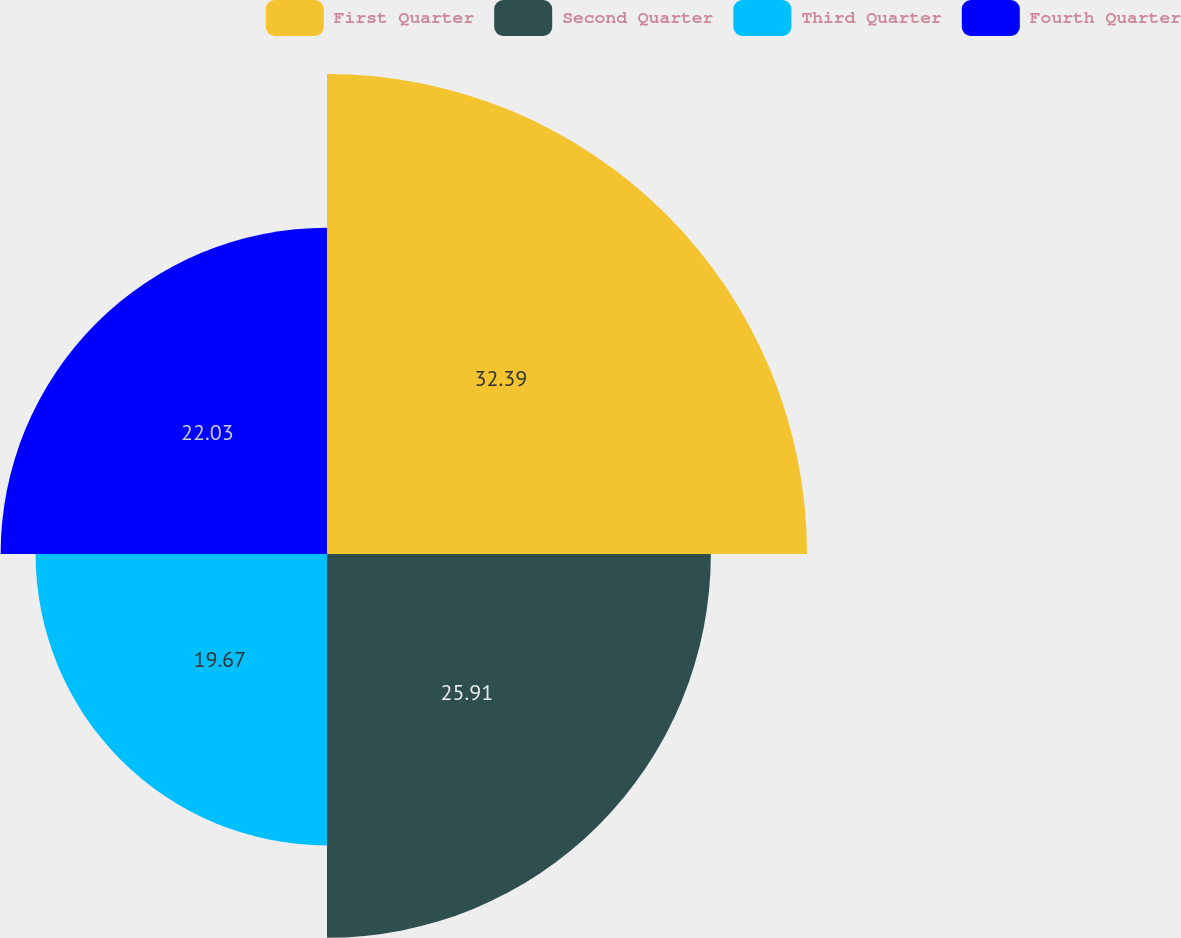<chart> <loc_0><loc_0><loc_500><loc_500><pie_chart><fcel>First Quarter<fcel>Second Quarter<fcel>Third Quarter<fcel>Fourth Quarter<nl><fcel>32.4%<fcel>25.91%<fcel>19.67%<fcel>22.03%<nl></chart> 